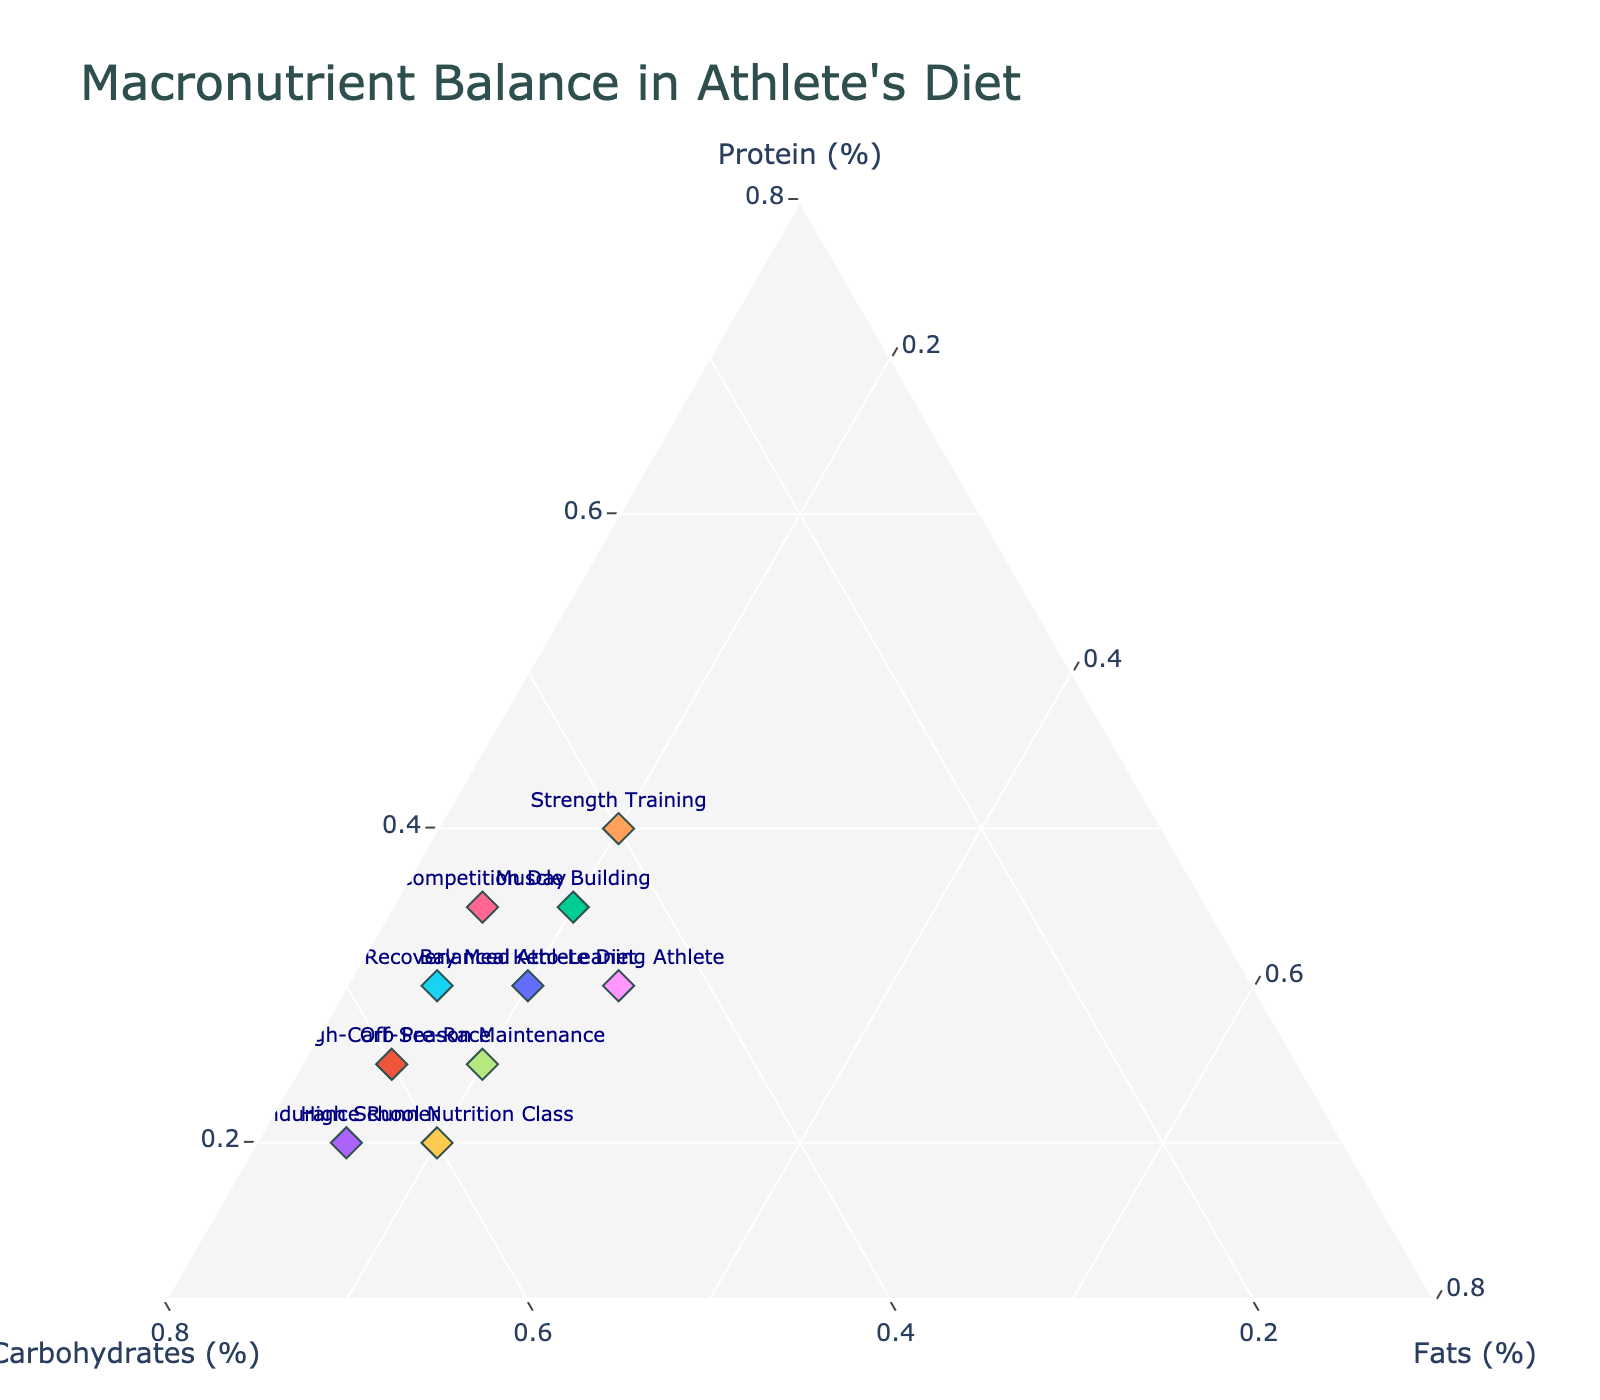What is the title of the figure? The title of the figure is located at the top and is designed to provide an immediate summary of the chart's content. Here, it is clearly written on top.
Answer: Macronutrient Balance in Athlete's Diet Which diet has the highest percentage of protein? To find the diet with the highest protein percentage, look at the "Protein" axis and identify the data point that is closest to it.
Answer: Strength Training What are the axes labeled in the figure? The axes are labeled to show the three components measured in the diet. These are indicated on the edges of the ternary plot.
Answer: Protein (%), Carbohydrates (%), Fats (%) Comparing the High-Carb Pre-Race and Off-Season Maintenance diets, which has a higher carbohydrate percentage? By observing the relative position of both diets along the "Carbohydrates" axis, we can find which has a higher value. High-Carb Pre-Race is higher on the Carbohydrates axis.
Answer: High-Carb Pre-Race What's the average percentage of fats across all diets shown in the plot? Sum the percentage of fats in all listed diets and divide by the number of diets (20+15+20+15+20+15+15+20+25+20 = 185, 185/10 = 18.5).
Answer: 18.5% Which two diets lie closest to each other on the plot? Evaluate the Euclidean distance between each pair of data points on the plot to find the closest pair. In this case, the "Recovery Meal" and "Competition Day" lie closest to each other.
Answer: Recovery Meal and Competition Day In which diet is the protein percentage exactly halfway between the highest and lowest values? Determine the highest (Strength Training, 40%) and lowest (Endurance Runner, 20%) protein values. The midpoint is (40 + 20) / 2 = 30. Look for diets with 30% protein.
Answer: Balanced Athlete Diet, Recovery Meal, and Keto-Leaning Athlete If you combine the macronutrient percentages of the Muscle Building and Endurance Runner diets, what is the resulting sum for each macronutrient? Add the respective percentages of the two diets for each macronutrient (Protein: 35 + 20 = 55, Carbohydrates: 45 + 65 = 110, Fats: 20 + 15 = 35).
Answer: Protein: 55%, Carbohydrates: 110%, Fats: 35% What is the difference in the percentage of fats between the Muscle Building and Keto-Leaning Athlete diets? Subtract the fat percentage of the Muscle Building diet from the Keto-Leaning Athlete diet (25 - 20).
Answer: 5% Which diet appears to have the most balanced distribution of macronutrients? A diet with the most balanced macronutrient distribution would have values closest to each other. Look for the diet with relatively equal distribution on the ternary plot.
Answer: Balanced Athlete Diet 